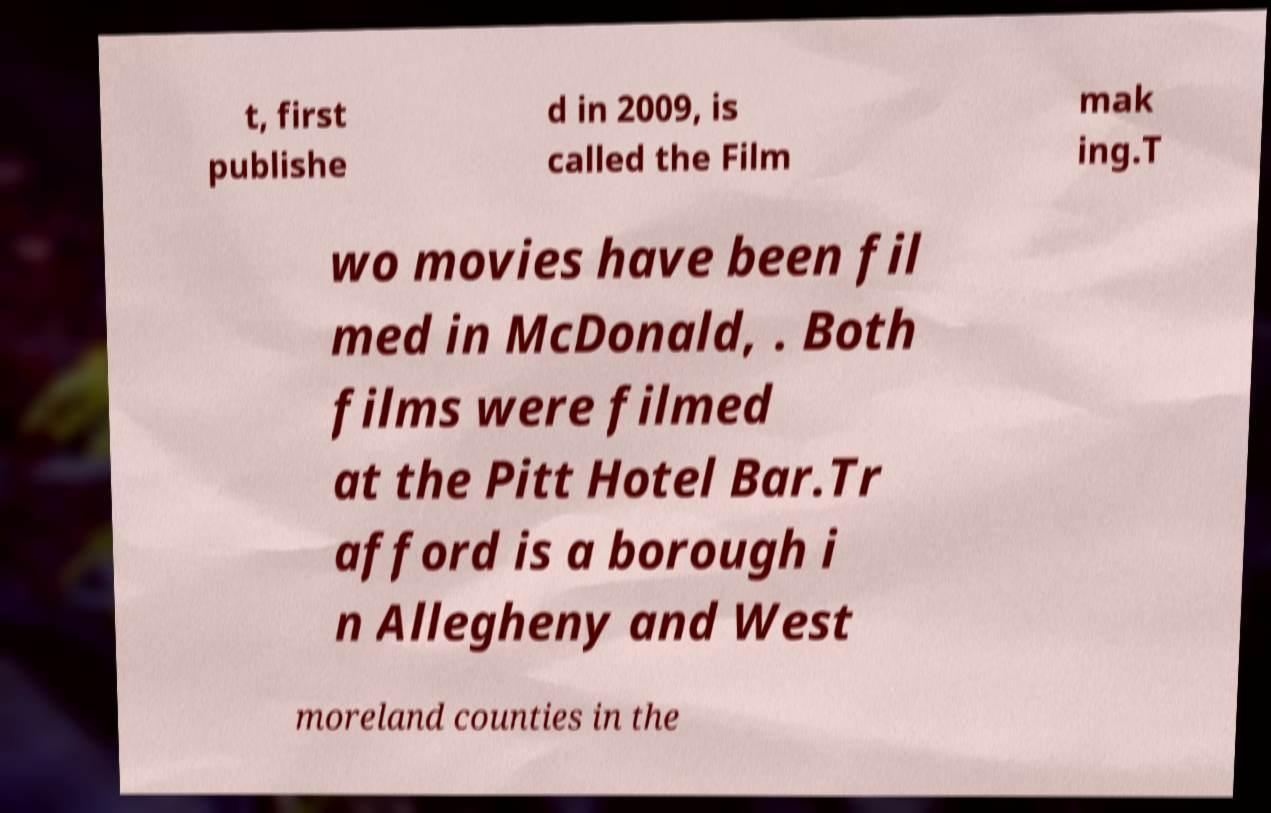Could you assist in decoding the text presented in this image and type it out clearly? t, first publishe d in 2009, is called the Film mak ing.T wo movies have been fil med in McDonald, . Both films were filmed at the Pitt Hotel Bar.Tr afford is a borough i n Allegheny and West moreland counties in the 